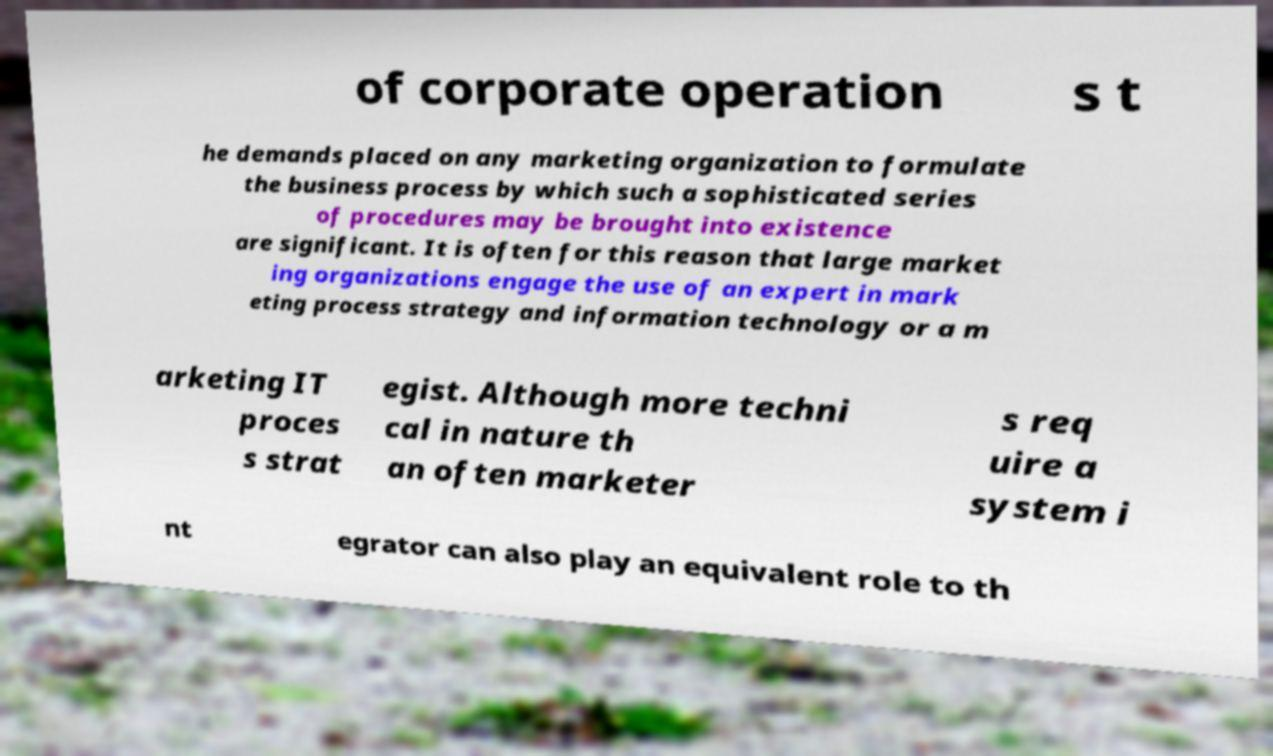Could you extract and type out the text from this image? of corporate operation s t he demands placed on any marketing organization to formulate the business process by which such a sophisticated series of procedures may be brought into existence are significant. It is often for this reason that large market ing organizations engage the use of an expert in mark eting process strategy and information technology or a m arketing IT proces s strat egist. Although more techni cal in nature th an often marketer s req uire a system i nt egrator can also play an equivalent role to th 